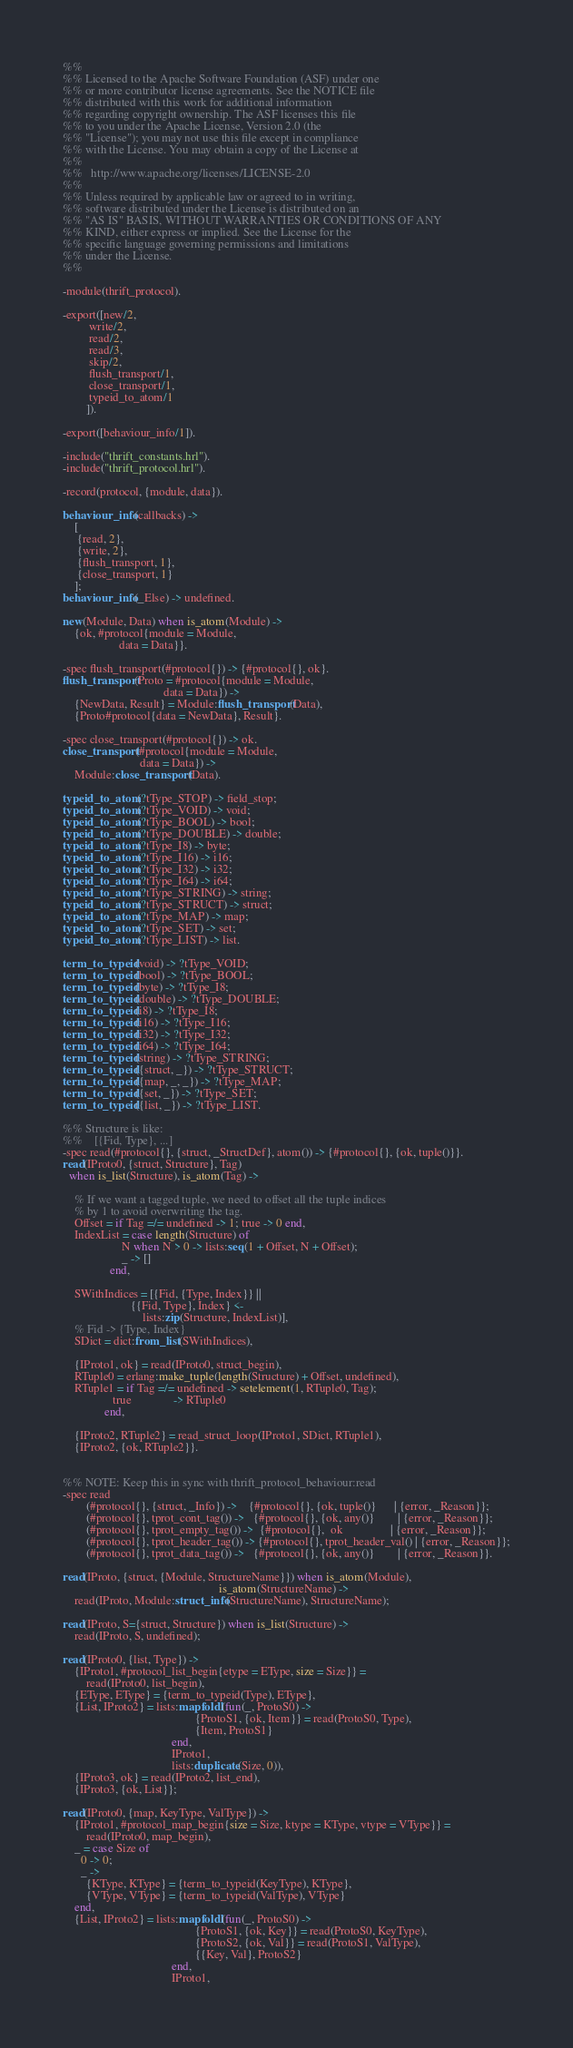Convert code to text. <code><loc_0><loc_0><loc_500><loc_500><_Erlang_>%%
%% Licensed to the Apache Software Foundation (ASF) under one
%% or more contributor license agreements. See the NOTICE file
%% distributed with this work for additional information
%% regarding copyright ownership. The ASF licenses this file
%% to you under the Apache License, Version 2.0 (the
%% "License"); you may not use this file except in compliance
%% with the License. You may obtain a copy of the License at
%%
%%   http://www.apache.org/licenses/LICENSE-2.0
%%
%% Unless required by applicable law or agreed to in writing,
%% software distributed under the License is distributed on an
%% "AS IS" BASIS, WITHOUT WARRANTIES OR CONDITIONS OF ANY
%% KIND, either express or implied. See the License for the
%% specific language governing permissions and limitations
%% under the License.
%%

-module(thrift_protocol).

-export([new/2,
         write/2,
         read/2,
         read/3,
         skip/2,
         flush_transport/1,
         close_transport/1,
         typeid_to_atom/1
        ]).

-export([behaviour_info/1]).

-include("thrift_constants.hrl").
-include("thrift_protocol.hrl").

-record(protocol, {module, data}).

behaviour_info(callbacks) ->
    [
     {read, 2},
     {write, 2},
     {flush_transport, 1},
     {close_transport, 1}
    ];
behaviour_info(_Else) -> undefined.

new(Module, Data) when is_atom(Module) ->
    {ok, #protocol{module = Module,
                   data = Data}}.

-spec flush_transport(#protocol{}) -> {#protocol{}, ok}.
flush_transport(Proto = #protocol{module = Module,
                                  data = Data}) ->
    {NewData, Result} = Module:flush_transport(Data),
    {Proto#protocol{data = NewData}, Result}.

-spec close_transport(#protocol{}) -> ok.
close_transport(#protocol{module = Module,
                          data = Data}) ->
    Module:close_transport(Data).

typeid_to_atom(?tType_STOP) -> field_stop;
typeid_to_atom(?tType_VOID) -> void;
typeid_to_atom(?tType_BOOL) -> bool;
typeid_to_atom(?tType_DOUBLE) -> double;
typeid_to_atom(?tType_I8) -> byte;
typeid_to_atom(?tType_I16) -> i16;
typeid_to_atom(?tType_I32) -> i32;
typeid_to_atom(?tType_I64) -> i64;
typeid_to_atom(?tType_STRING) -> string;
typeid_to_atom(?tType_STRUCT) -> struct;
typeid_to_atom(?tType_MAP) -> map;
typeid_to_atom(?tType_SET) -> set;
typeid_to_atom(?tType_LIST) -> list.

term_to_typeid(void) -> ?tType_VOID;
term_to_typeid(bool) -> ?tType_BOOL;
term_to_typeid(byte) -> ?tType_I8;
term_to_typeid(double) -> ?tType_DOUBLE;
term_to_typeid(i8) -> ?tType_I8;
term_to_typeid(i16) -> ?tType_I16;
term_to_typeid(i32) -> ?tType_I32;
term_to_typeid(i64) -> ?tType_I64;
term_to_typeid(string) -> ?tType_STRING;
term_to_typeid({struct, _}) -> ?tType_STRUCT;
term_to_typeid({map, _, _}) -> ?tType_MAP;
term_to_typeid({set, _}) -> ?tType_SET;
term_to_typeid({list, _}) -> ?tType_LIST.

%% Structure is like:
%%    [{Fid, Type}, ...]
-spec read(#protocol{}, {struct, _StructDef}, atom()) -> {#protocol{}, {ok, tuple()}}.
read(IProto0, {struct, Structure}, Tag)
  when is_list(Structure), is_atom(Tag) ->

    % If we want a tagged tuple, we need to offset all the tuple indices
    % by 1 to avoid overwriting the tag.
    Offset = if Tag =/= undefined -> 1; true -> 0 end,
    IndexList = case length(Structure) of
                    N when N > 0 -> lists:seq(1 + Offset, N + Offset);
                    _ -> []
                end,

    SWithIndices = [{Fid, {Type, Index}} ||
                       {{Fid, Type}, Index} <-
                           lists:zip(Structure, IndexList)],
    % Fid -> {Type, Index}
    SDict = dict:from_list(SWithIndices),

    {IProto1, ok} = read(IProto0, struct_begin),
    RTuple0 = erlang:make_tuple(length(Structure) + Offset, undefined),
    RTuple1 = if Tag =/= undefined -> setelement(1, RTuple0, Tag);
                 true              -> RTuple0
              end,

    {IProto2, RTuple2} = read_struct_loop(IProto1, SDict, RTuple1),
    {IProto2, {ok, RTuple2}}.


%% NOTE: Keep this in sync with thrift_protocol_behaviour:read
-spec read
        (#protocol{}, {struct, _Info}) ->    {#protocol{}, {ok, tuple()}      | {error, _Reason}};
        (#protocol{}, tprot_cont_tag()) ->   {#protocol{}, {ok, any()}        | {error, _Reason}};
        (#protocol{}, tprot_empty_tag()) ->  {#protocol{},  ok                | {error, _Reason}};
        (#protocol{}, tprot_header_tag()) -> {#protocol{}, tprot_header_val() | {error, _Reason}};
        (#protocol{}, tprot_data_tag()) ->   {#protocol{}, {ok, any()}        | {error, _Reason}}.

read(IProto, {struct, {Module, StructureName}}) when is_atom(Module),
                                                     is_atom(StructureName) ->
    read(IProto, Module:struct_info(StructureName), StructureName);

read(IProto, S={struct, Structure}) when is_list(Structure) ->
    read(IProto, S, undefined);

read(IProto0, {list, Type}) ->
    {IProto1, #protocol_list_begin{etype = EType, size = Size}} =
        read(IProto0, list_begin),
    {EType, EType} = {term_to_typeid(Type), EType},
    {List, IProto2} = lists:mapfoldl(fun(_, ProtoS0) ->
                                             {ProtoS1, {ok, Item}} = read(ProtoS0, Type),
                                             {Item, ProtoS1}
                                     end,
                                     IProto1,
                                     lists:duplicate(Size, 0)),
    {IProto3, ok} = read(IProto2, list_end),
    {IProto3, {ok, List}};

read(IProto0, {map, KeyType, ValType}) ->
    {IProto1, #protocol_map_begin{size = Size, ktype = KType, vtype = VType}} =
        read(IProto0, map_begin),
    _ = case Size of
      0 -> 0;
      _ ->
        {KType, KType} = {term_to_typeid(KeyType), KType},
        {VType, VType} = {term_to_typeid(ValType), VType}
    end,
    {List, IProto2} = lists:mapfoldl(fun(_, ProtoS0) ->
                                             {ProtoS1, {ok, Key}} = read(ProtoS0, KeyType),
                                             {ProtoS2, {ok, Val}} = read(ProtoS1, ValType),
                                             {{Key, Val}, ProtoS2}
                                     end,
                                     IProto1,</code> 